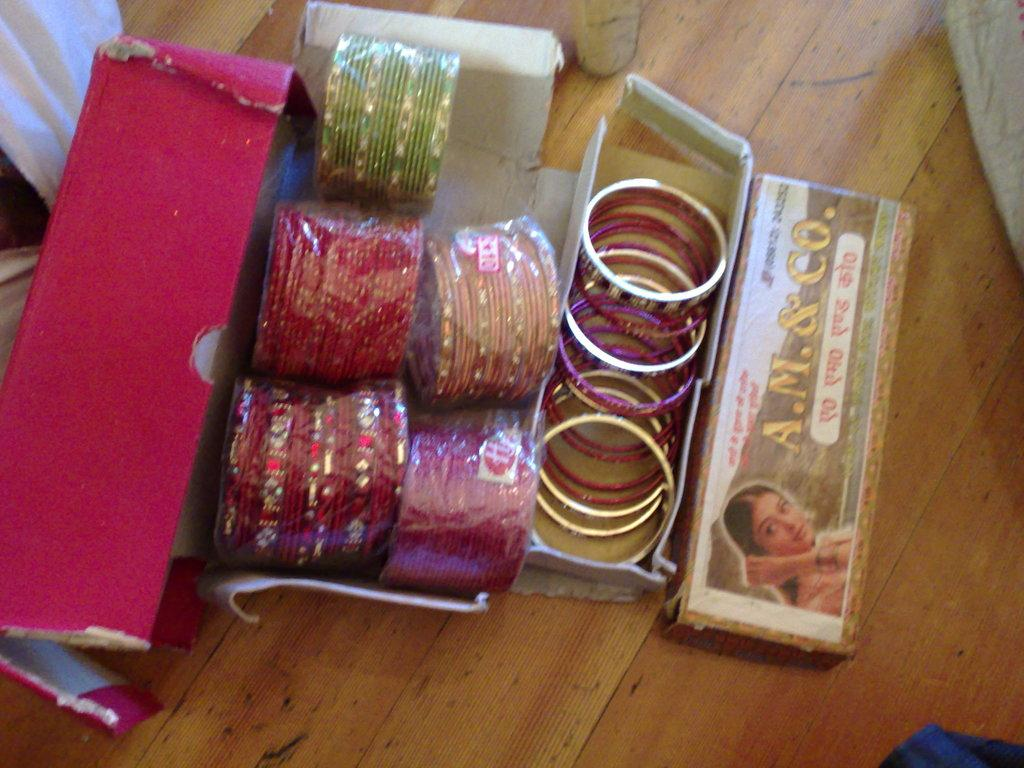What is the color of the wooden surface in the image? The wooden surface in the image is brown in color. What objects are placed on the wooden surface? There are cardboard boxes on the wooden surface. What items are inside the cardboard boxes? The boxes contain bangles. What type of mine is visible in the image? There is no mine present in the image. Can you solve the riddle written on the cardboard boxes? There is no riddle written on the cardboard boxes in the image. 